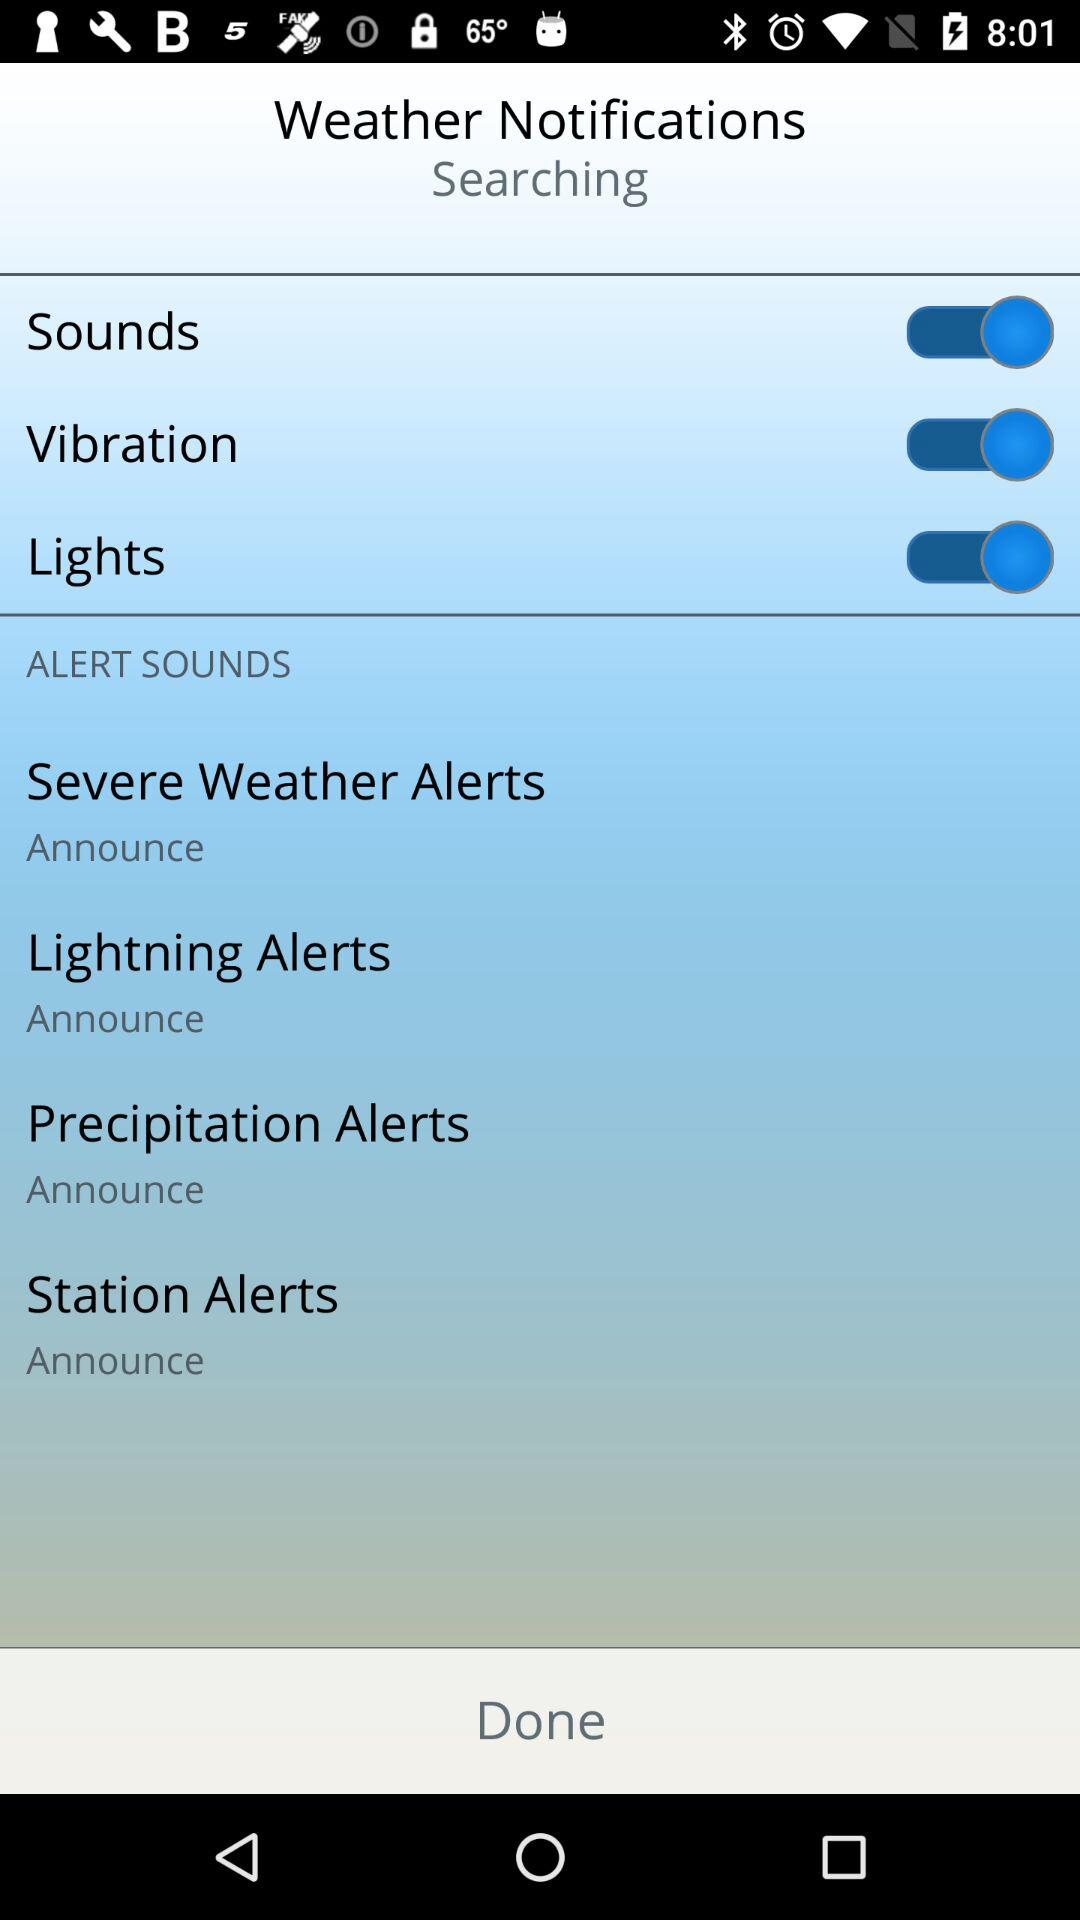What is the status of the "Sounds"? The status is "on". 